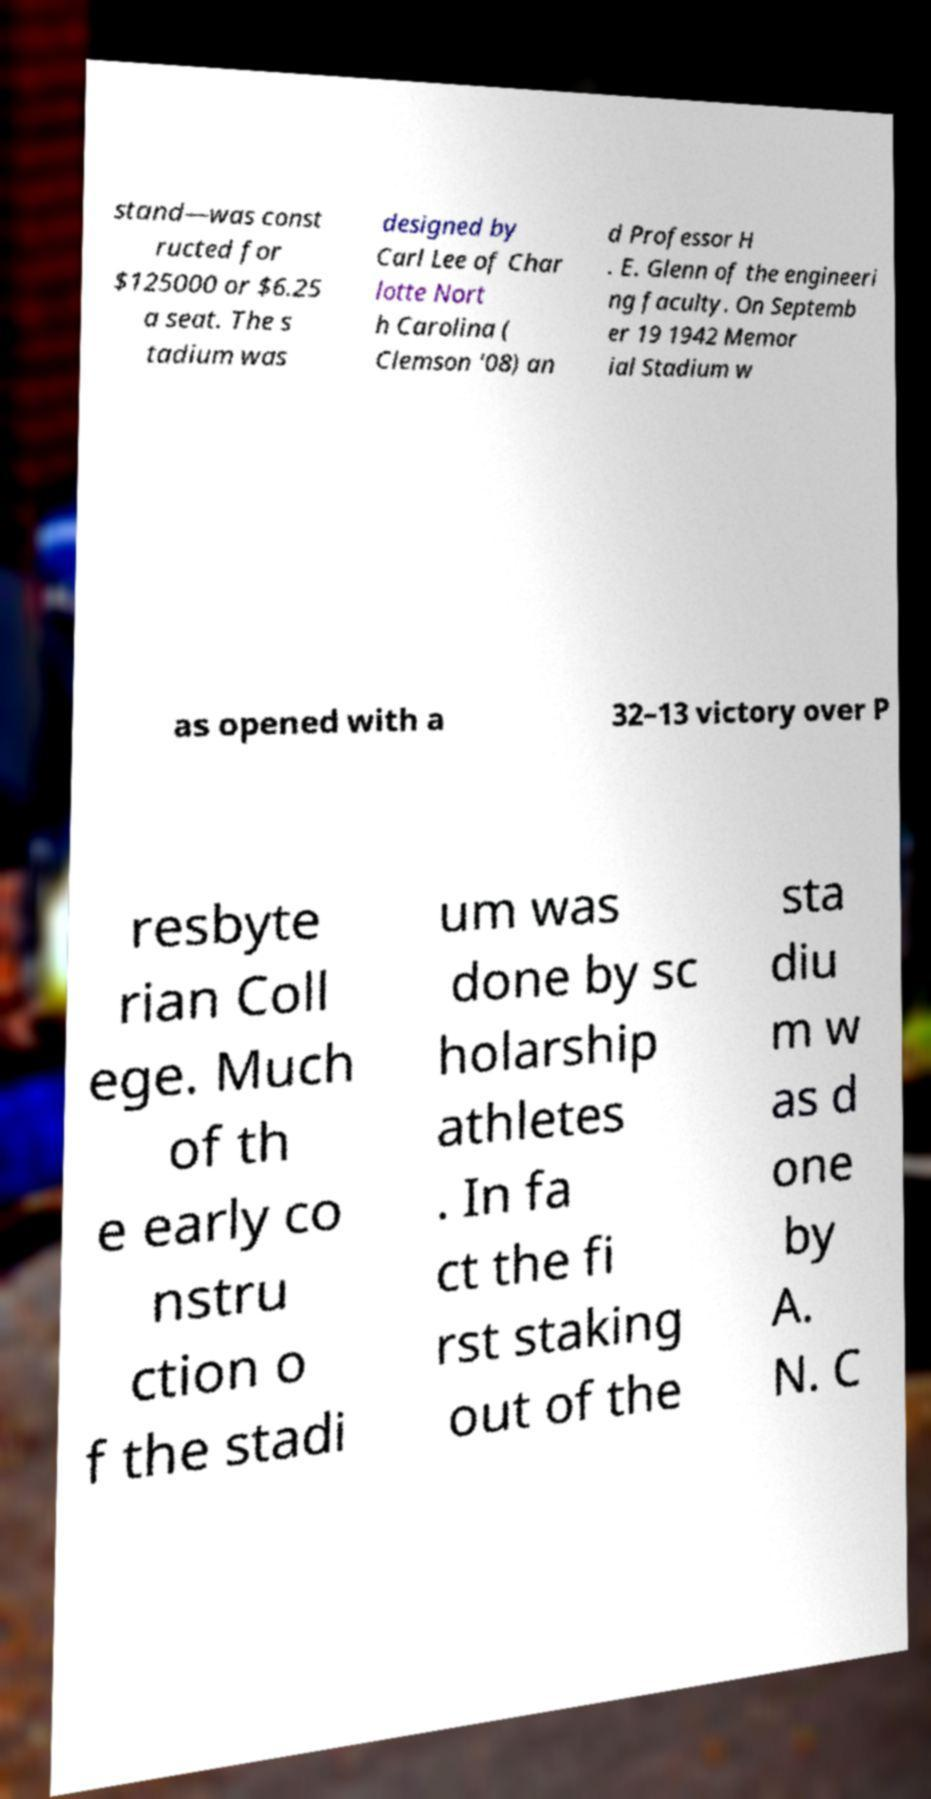I need the written content from this picture converted into text. Can you do that? stand—was const ructed for $125000 or $6.25 a seat. The s tadium was designed by Carl Lee of Char lotte Nort h Carolina ( Clemson '08) an d Professor H . E. Glenn of the engineeri ng faculty. On Septemb er 19 1942 Memor ial Stadium w as opened with a 32–13 victory over P resbyte rian Coll ege. Much of th e early co nstru ction o f the stadi um was done by sc holarship athletes . In fa ct the fi rst staking out of the sta diu m w as d one by A. N. C 